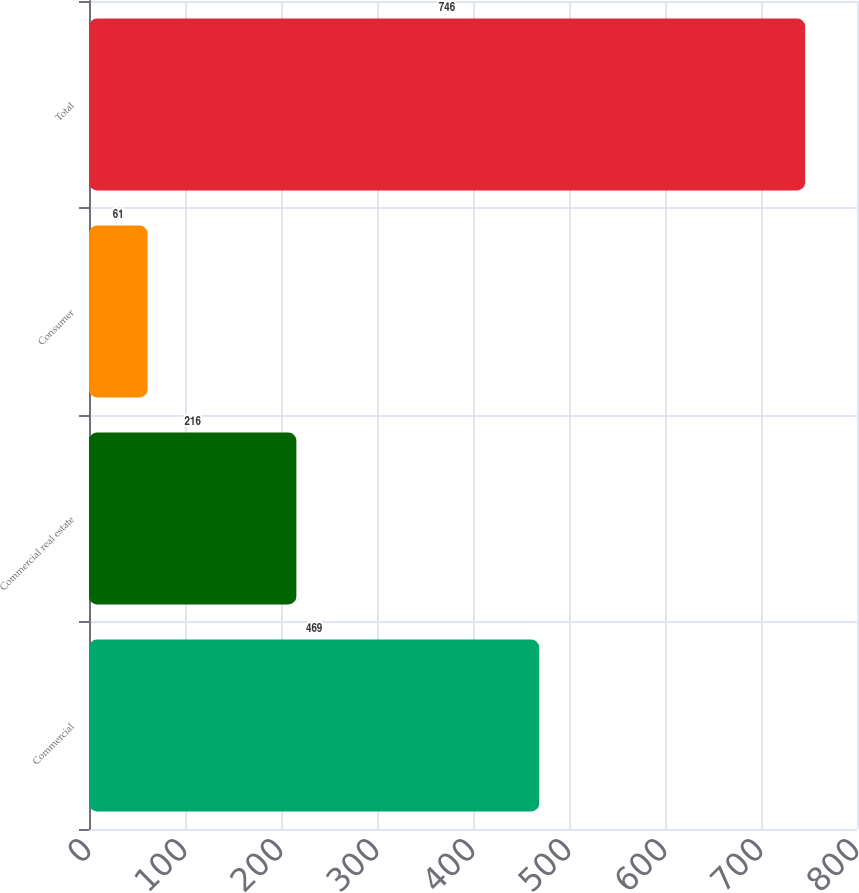Convert chart to OTSL. <chart><loc_0><loc_0><loc_500><loc_500><bar_chart><fcel>Commercial<fcel>Commercial real estate<fcel>Consumer<fcel>Total<nl><fcel>469<fcel>216<fcel>61<fcel>746<nl></chart> 